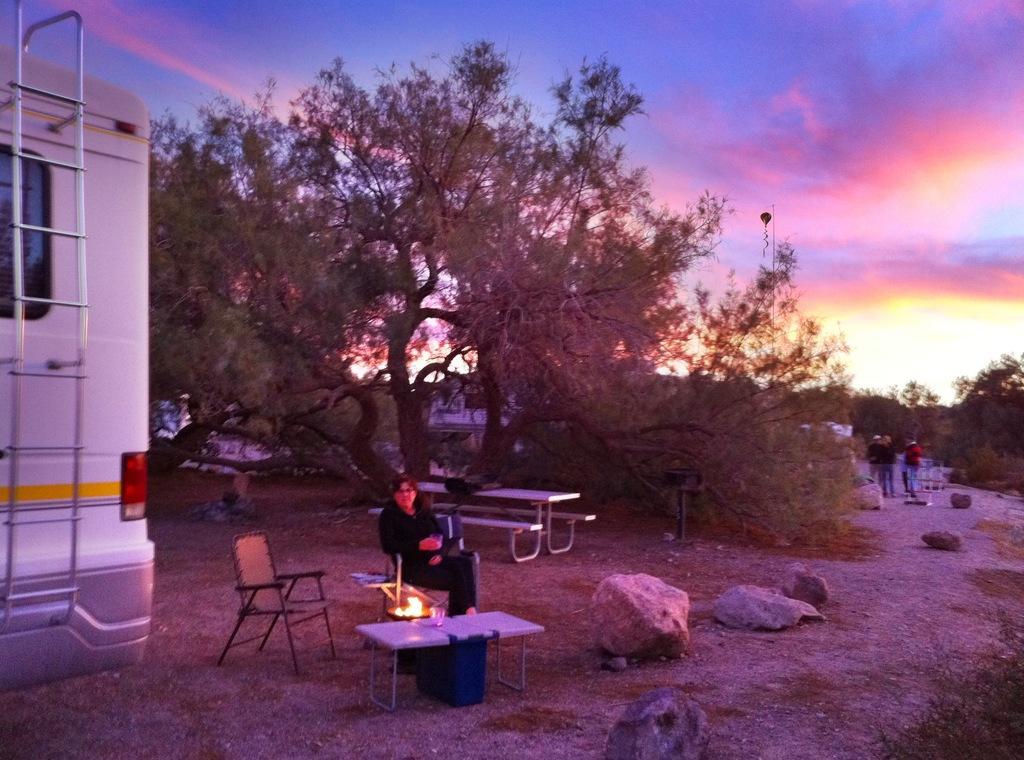In one or two sentences, can you explain what this image depicts? In the picture we can see a path with some grass particles and some plants and we can also see some rocks, benches, and table and near it we can see a man sitting on the chair and we can see another chair beside him and a vehicle near it and in the background we can see some tree and some people are standing on the path and behind them also we can see full of trees and sky with sunshine. 